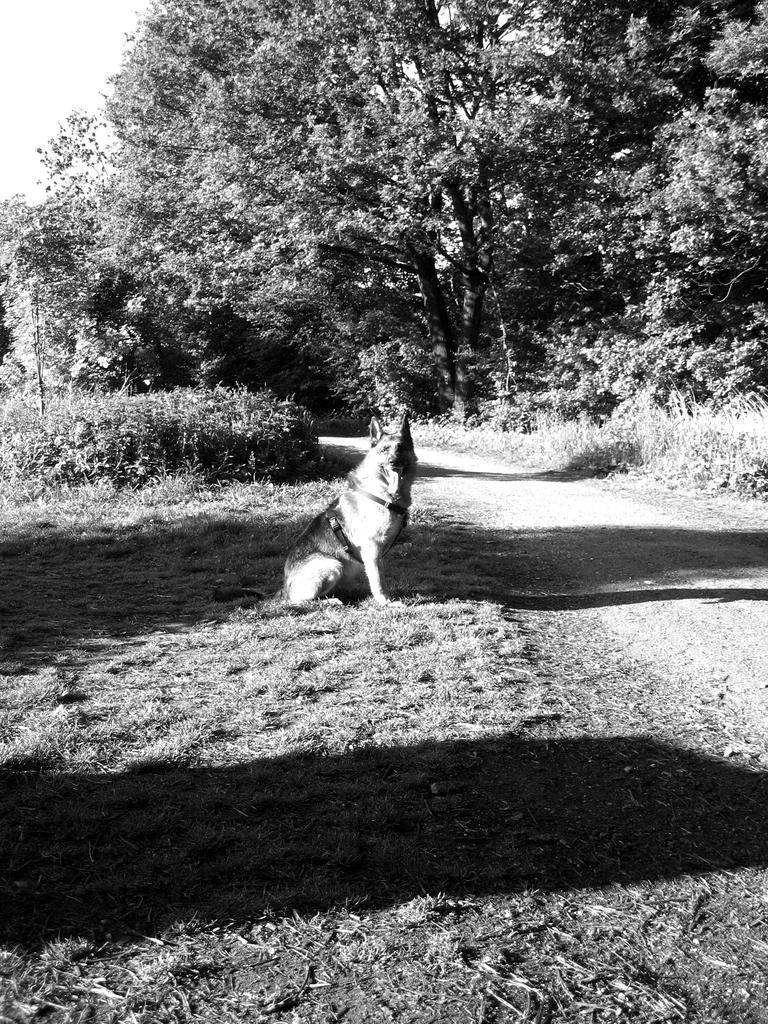Describe this image in one or two sentences. This is a black and white image. In this image there is a road. On the sides of the road there are trees and plants. Also there is a dog. 